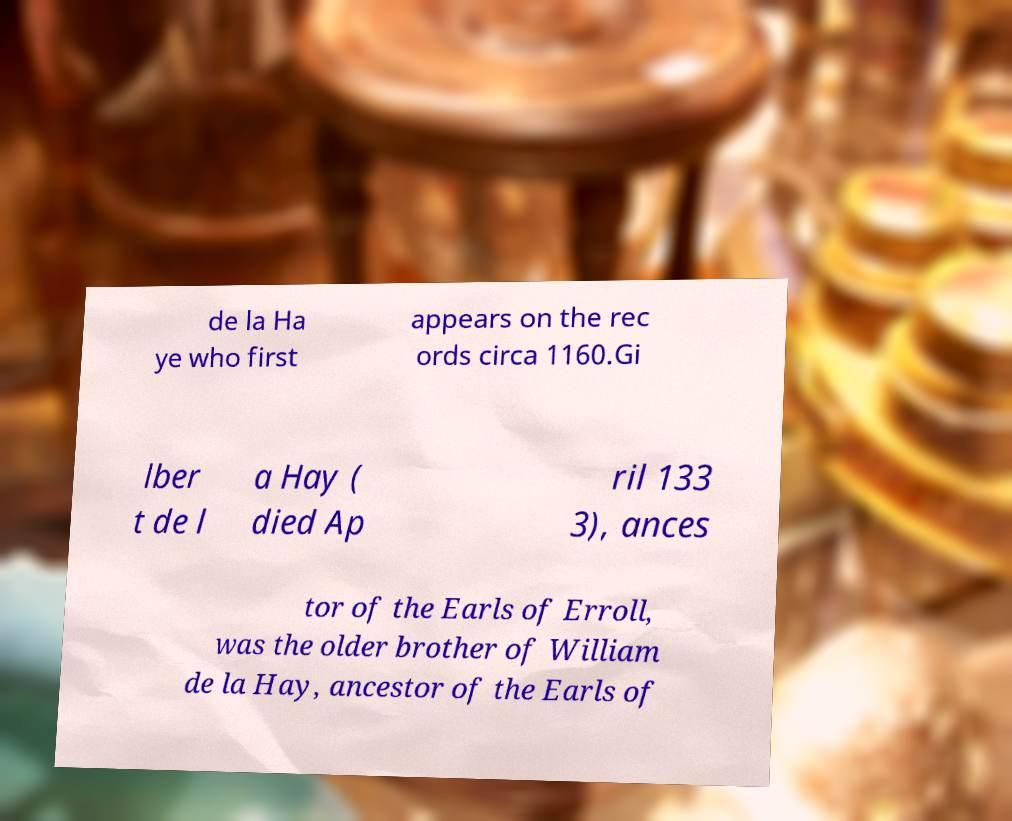For documentation purposes, I need the text within this image transcribed. Could you provide that? de la Ha ye who first appears on the rec ords circa 1160.Gi lber t de l a Hay ( died Ap ril 133 3), ances tor of the Earls of Erroll, was the older brother of William de la Hay, ancestor of the Earls of 